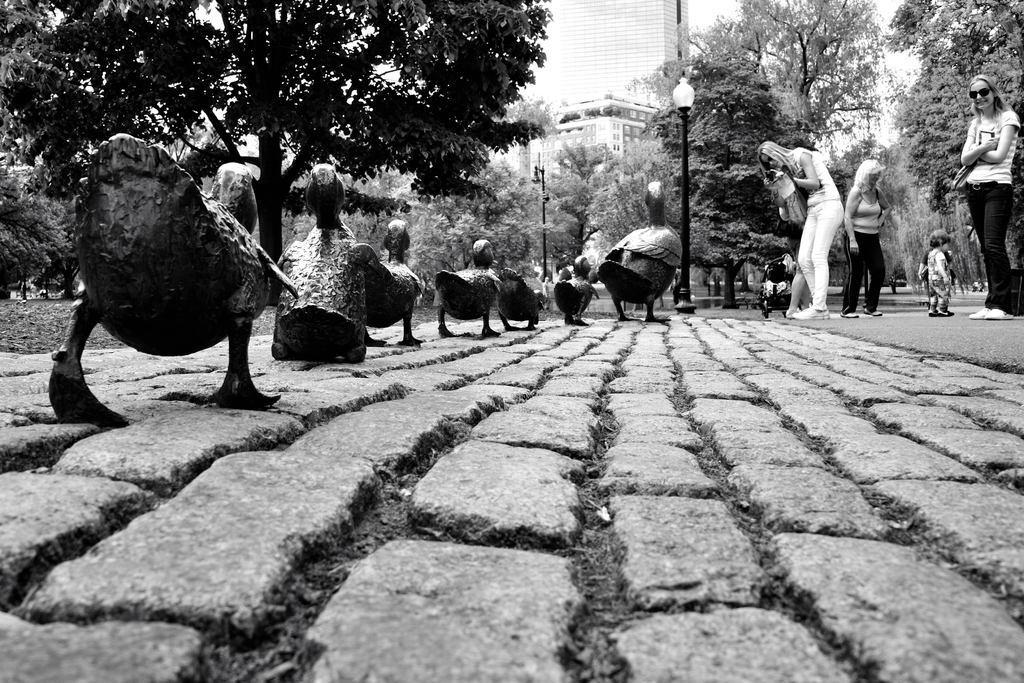Please provide a concise description of this image. In this picture there are sculptures of birds. On the right side of the image there are group of people standing on the road. At the back there are buildings, trees and poles. At the top there is sky. At the bottom there is a road and there is grass. 